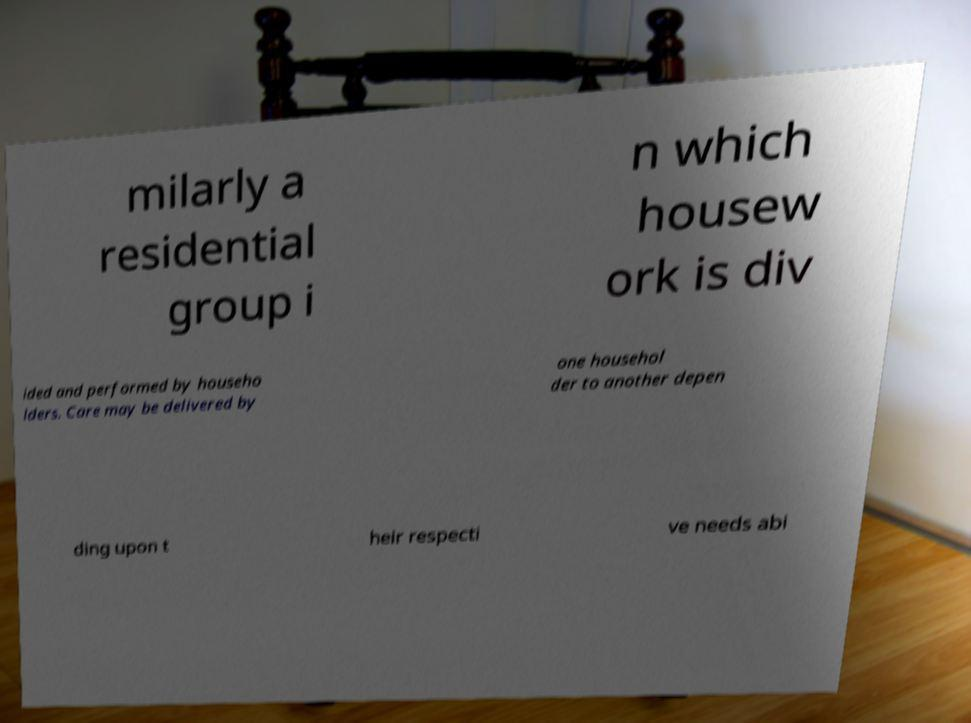Could you extract and type out the text from this image? milarly a residential group i n which housew ork is div ided and performed by househo lders. Care may be delivered by one househol der to another depen ding upon t heir respecti ve needs abi 